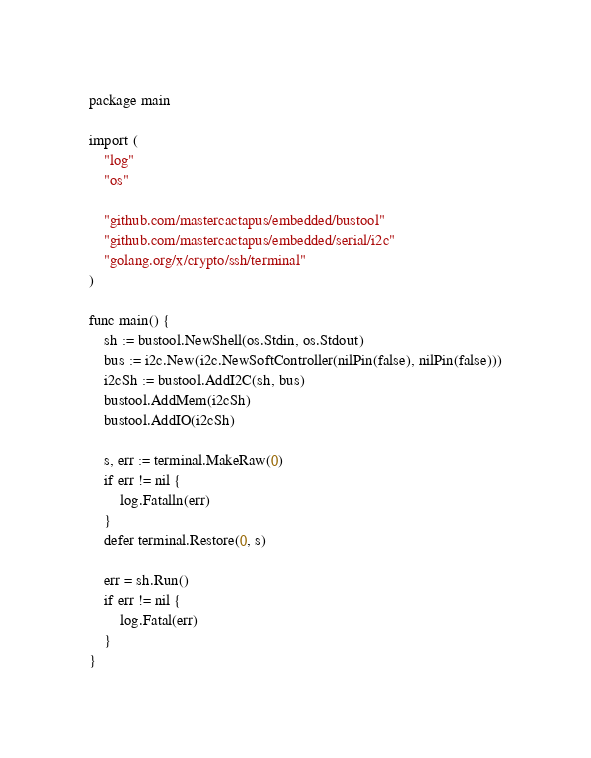<code> <loc_0><loc_0><loc_500><loc_500><_Go_>package main

import (
	"log"
	"os"

	"github.com/mastercactapus/embedded/bustool"
	"github.com/mastercactapus/embedded/serial/i2c"
	"golang.org/x/crypto/ssh/terminal"
)

func main() {
	sh := bustool.NewShell(os.Stdin, os.Stdout)
	bus := i2c.New(i2c.NewSoftController(nilPin(false), nilPin(false)))
	i2cSh := bustool.AddI2C(sh, bus)
	bustool.AddMem(i2cSh)
	bustool.AddIO(i2cSh)

	s, err := terminal.MakeRaw(0)
	if err != nil {
		log.Fatalln(err)
	}
	defer terminal.Restore(0, s)

	err = sh.Run()
	if err != nil {
		log.Fatal(err)
	}
}
</code> 